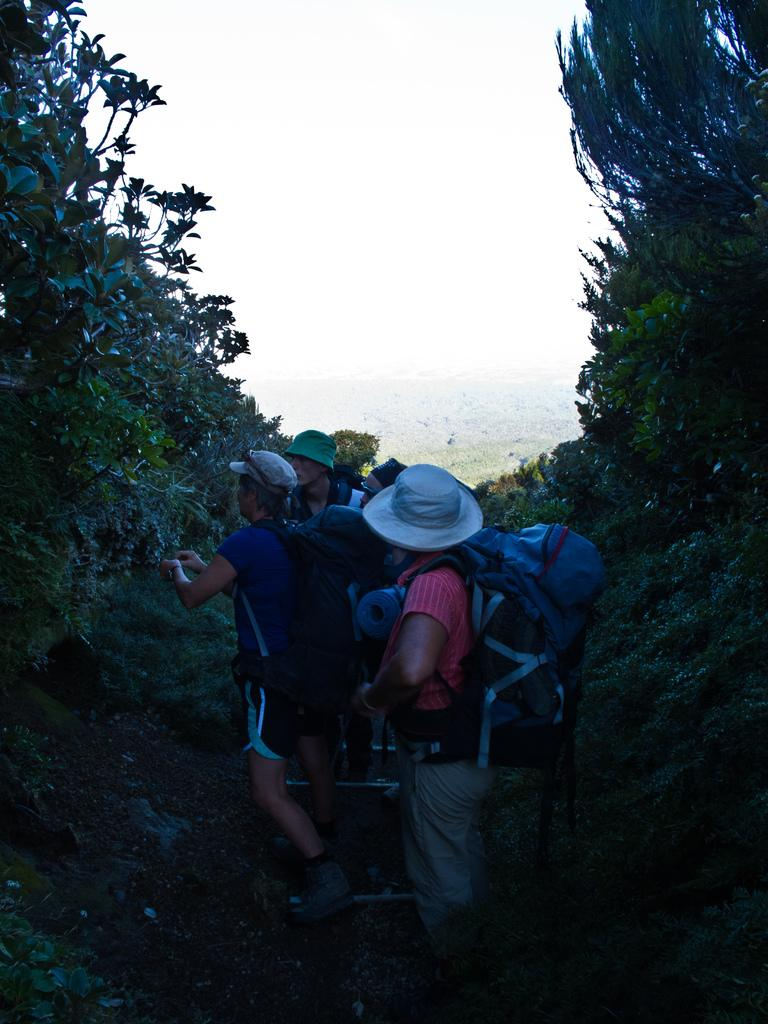What is the main subject of the image? The main subject of the image is a group of people. What are the people in the image doing? The people are standing in the image. What are the people wearing on their heads? The people are wearing hats in the image. What type of natural environment can be seen in the image? There are trees visible in the image. What type of bone can be seen in the image? There is no bone present in the image. 